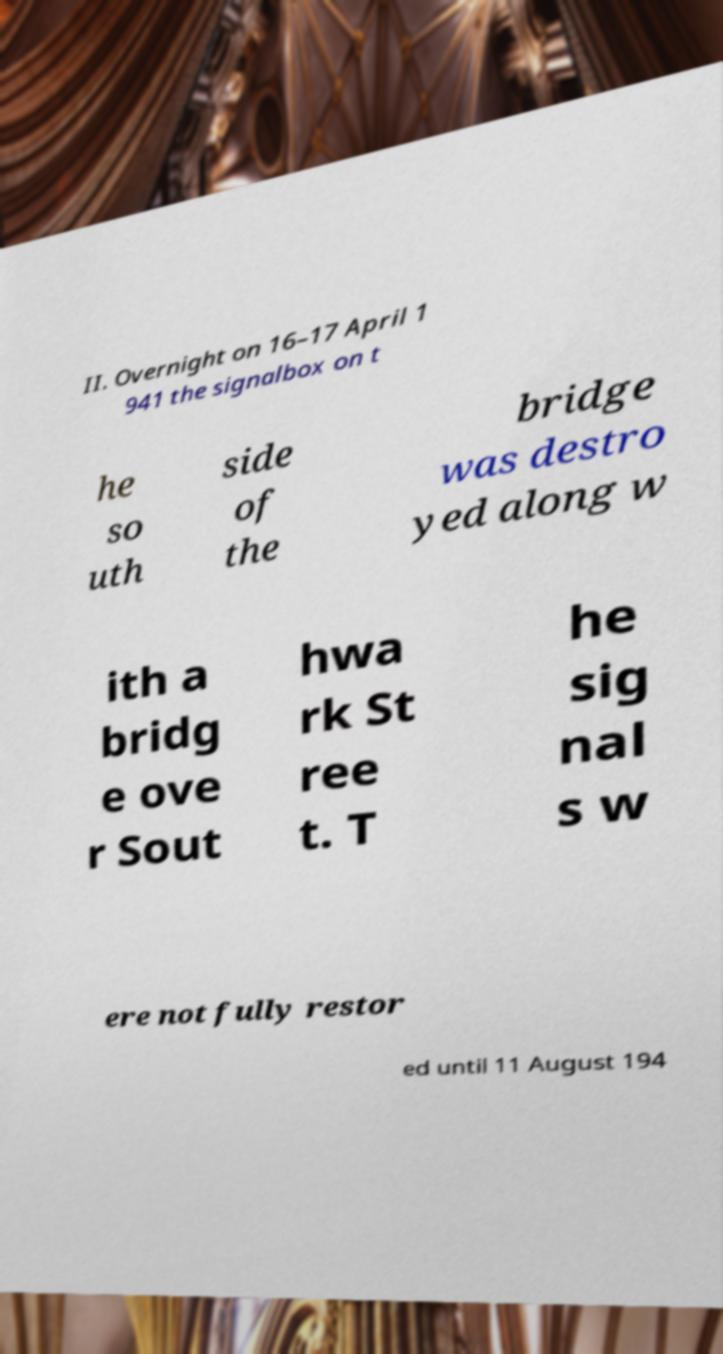Could you assist in decoding the text presented in this image and type it out clearly? II. Overnight on 16–17 April 1 941 the signalbox on t he so uth side of the bridge was destro yed along w ith a bridg e ove r Sout hwa rk St ree t. T he sig nal s w ere not fully restor ed until 11 August 194 